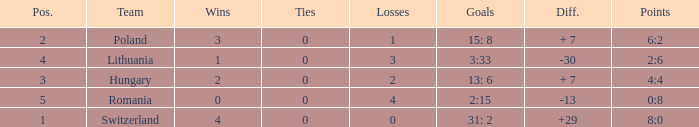Which team had a position greater than 1 and less than 2 losses? Poland. 